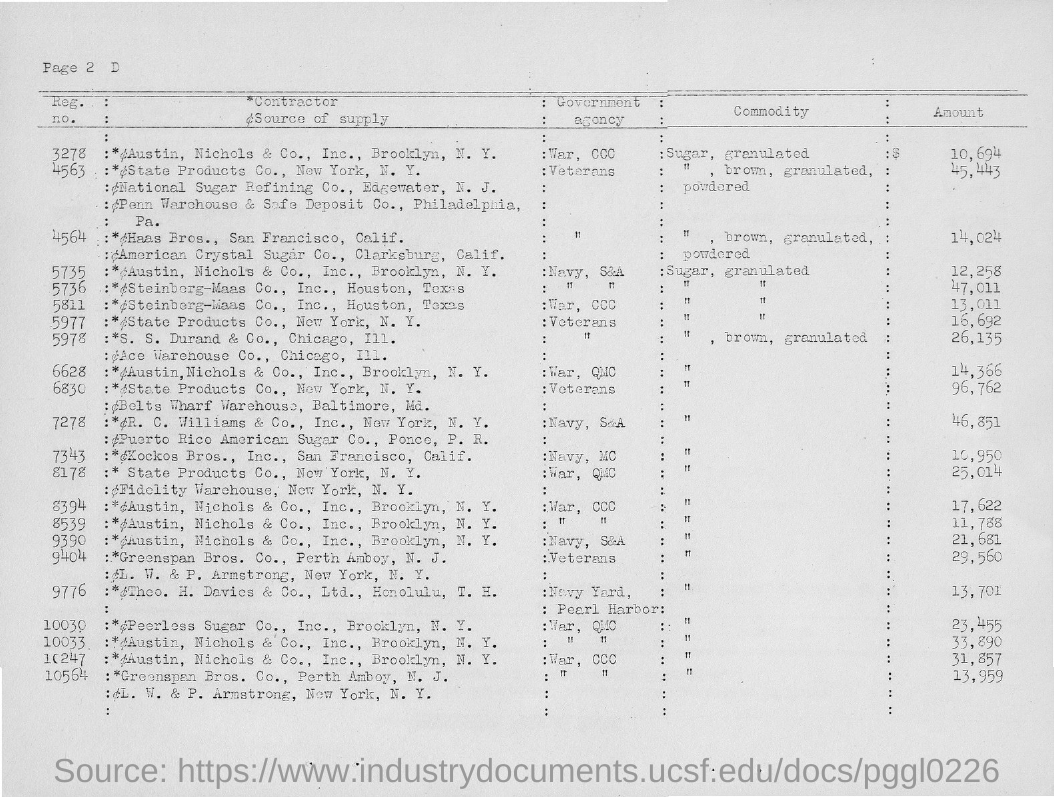Outline some significant characteristics in this image. The amount of the commodity with registration number 10033 is 33,890. According to the provided registration number, the amount of the commodity is 10,694. The amount of the commodity with registration number 10564 is 13,959. The amount of the commodity with registration number 10247 is 31,857. 